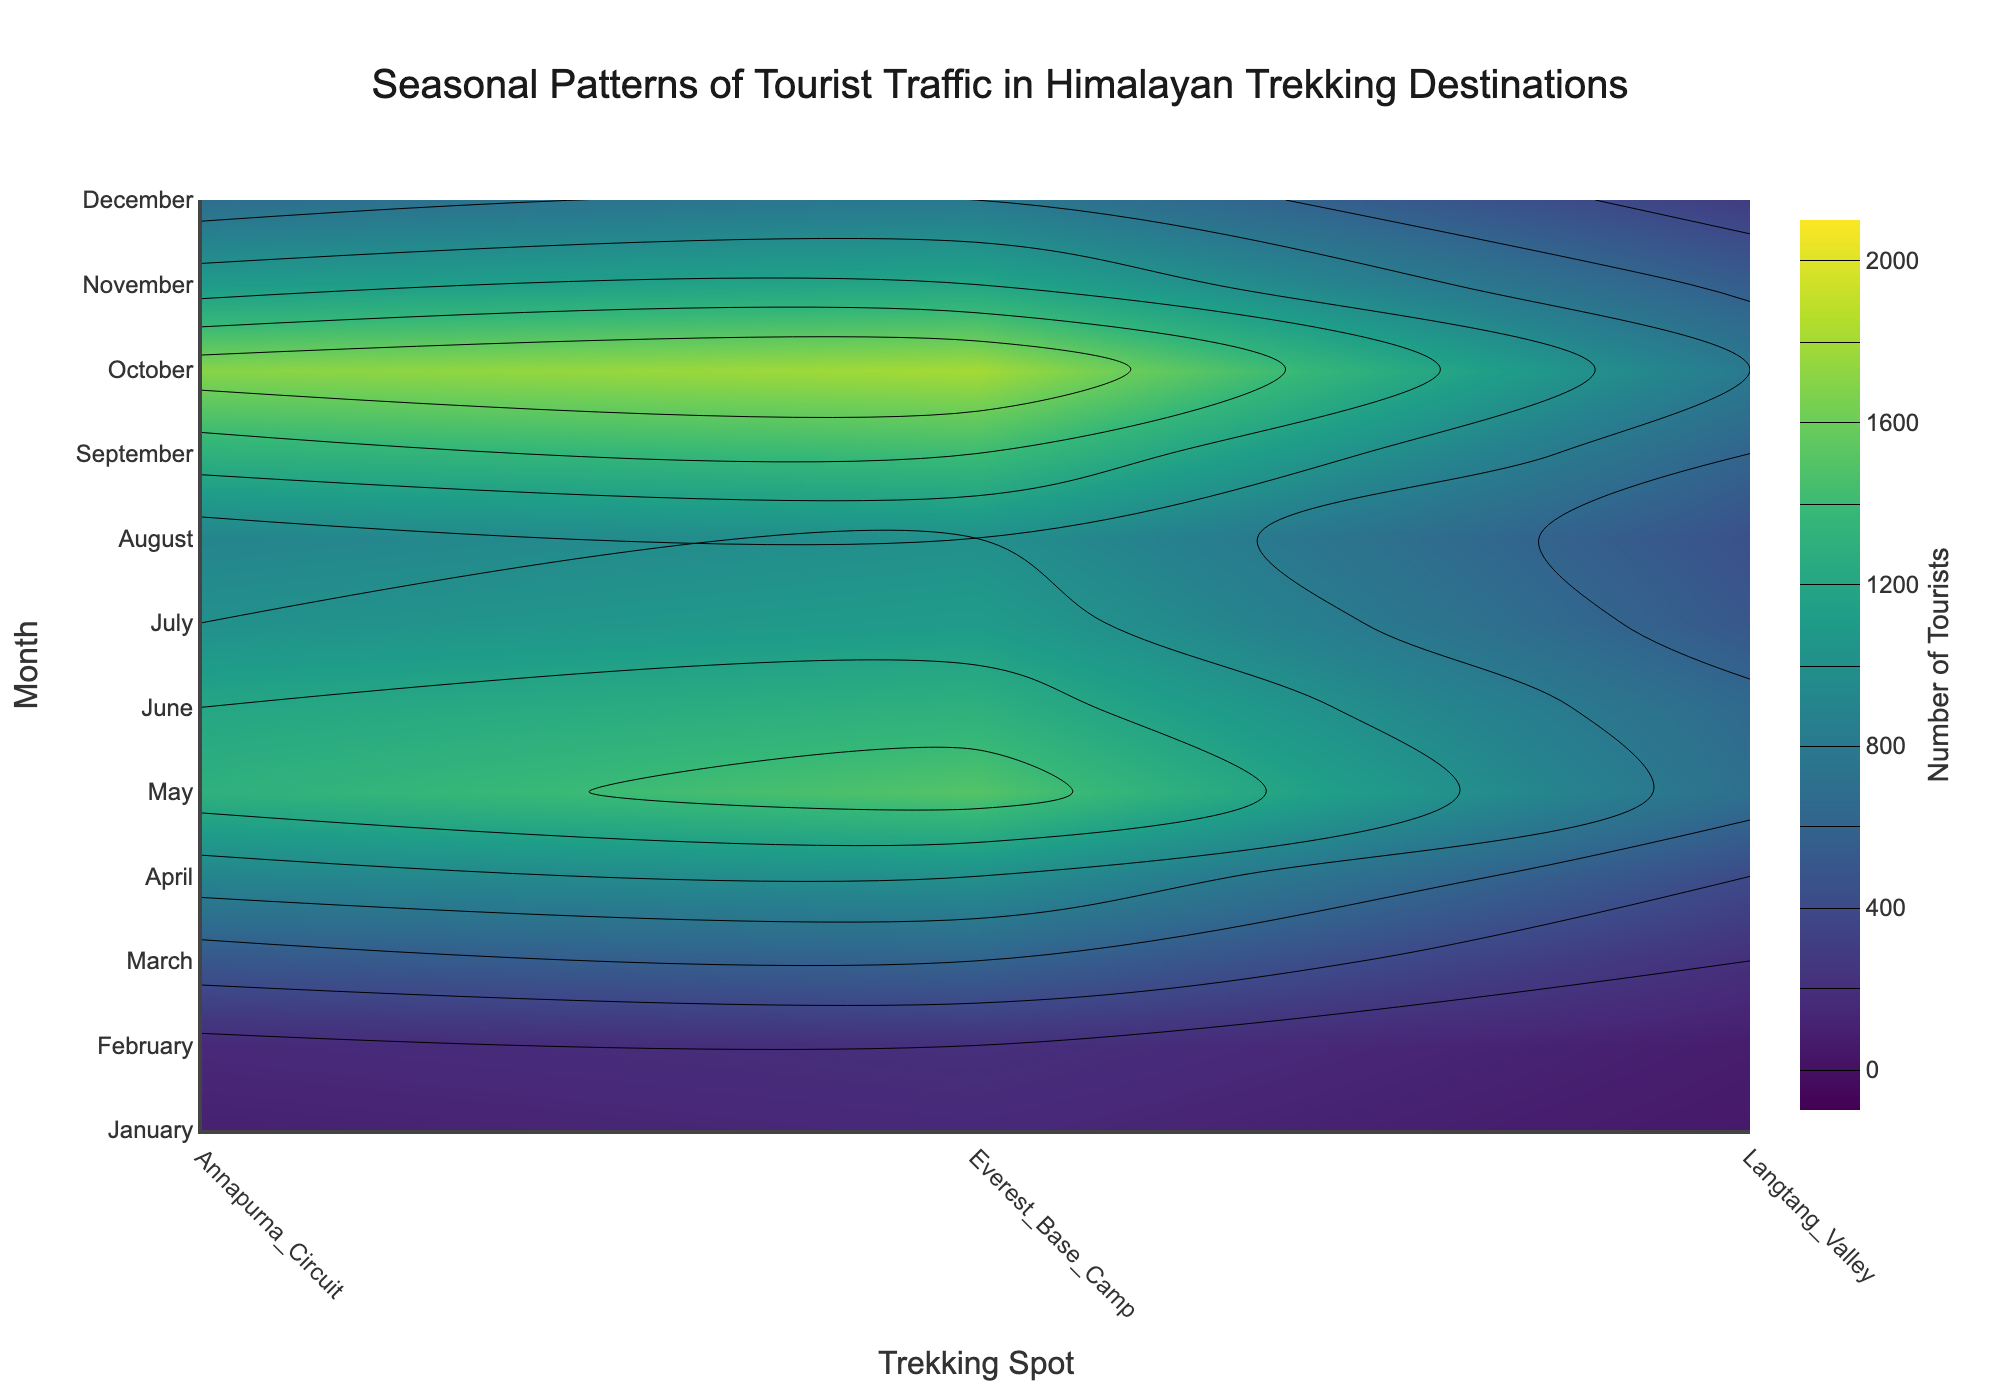How many trekking spots are covered in the contour plot? Count the number of different labels on the x-axis representing trekking spots.
Answer: 3 What is the season with the highest traffic for Everest Base Camp? Look for the month with the highest contour value in the Everest Base Camp's column.
Answer: October Which trekking spot has the least number of tourists in January? Identify the contour value for each trekking spot in January, find the minimum.
Answer: Langtang Valley Compare the tourist traffic for Everest Base Camp in April and August. Which month has more visitors? Look at the contour plot values for Everest Base Camp in April and August and compare them.
Answer: April During which months does Annapurna Circuit see over 1500 tourists? Identify the months in the Annapurna Circuit's column where the contour values are greater than 1500.
Answer: May, October What's the average number of tourists for Langtang Valley from March to May? Sum the contour values of Langtang Valley for March, April, and May, then divide by 3.
Answer: 433.33 Which spot has the most consistent tourist traffic throughout the year? Examine the contour values for each trekking spot across all months; the spot with the smallest variance indicates consistency.
Answer: Langtang Valley How does tourist traffic in July compare in all three trekking spots? Look at the contour values for each trekking spot in July and compare them.
Answer: Everest Base Camp > Annapurna Circuit > Langtang Valley In which month does Annapurna Circuit have exactly the same number of tourists as Langtang Valley? Identify the months in which the contour values for Annapurna Circuit and Langtang Valley columns match exactly.
Answer: July What's the biggest increase in tourist traffic in any of the trekking spots from one month to the next? Calculate the monthly increase for each trekking spot and identify the largest value.
Answer: Everest Base Camp (February to March) 